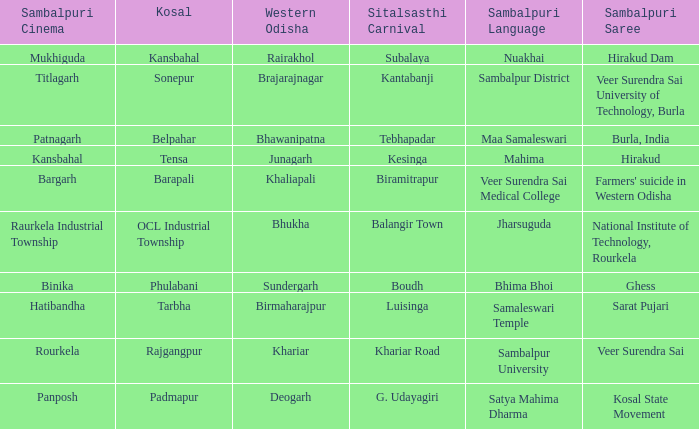What is the sambalpuri saree with a samaleswari temple as sambalpuri language? Sarat Pujari. 